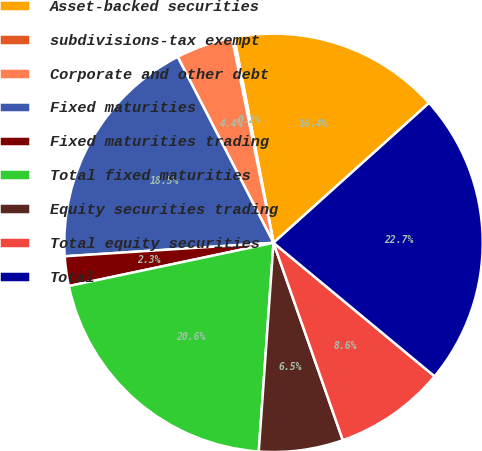Convert chart to OTSL. <chart><loc_0><loc_0><loc_500><loc_500><pie_chart><fcel>Asset-backed securities<fcel>subdivisions-tax exempt<fcel>Corporate and other debt<fcel>Fixed maturities<fcel>Fixed maturities trading<fcel>Total fixed maturities<fcel>Equity securities trading<fcel>Total equity securities<fcel>Total<nl><fcel>16.35%<fcel>0.18%<fcel>4.39%<fcel>18.45%<fcel>2.29%<fcel>20.56%<fcel>6.5%<fcel>8.61%<fcel>22.67%<nl></chart> 